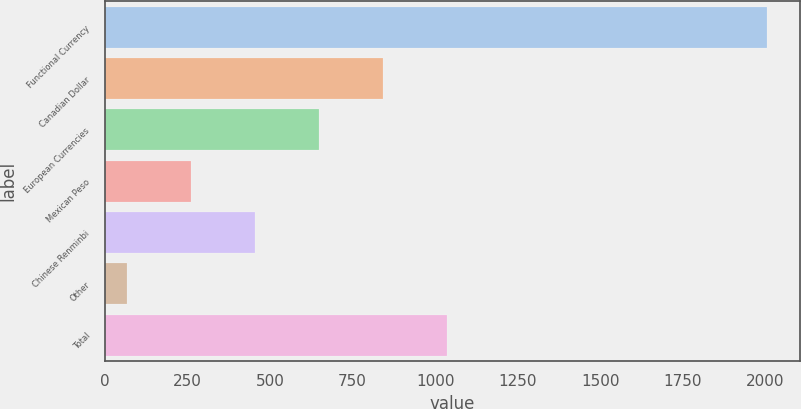<chart> <loc_0><loc_0><loc_500><loc_500><bar_chart><fcel>Functional Currency<fcel>Canadian Dollar<fcel>European Currencies<fcel>Mexican Peso<fcel>Chinese Renminbi<fcel>Other<fcel>Total<nl><fcel>2006<fcel>841.94<fcel>647.93<fcel>259.91<fcel>453.92<fcel>65.9<fcel>1035.95<nl></chart> 